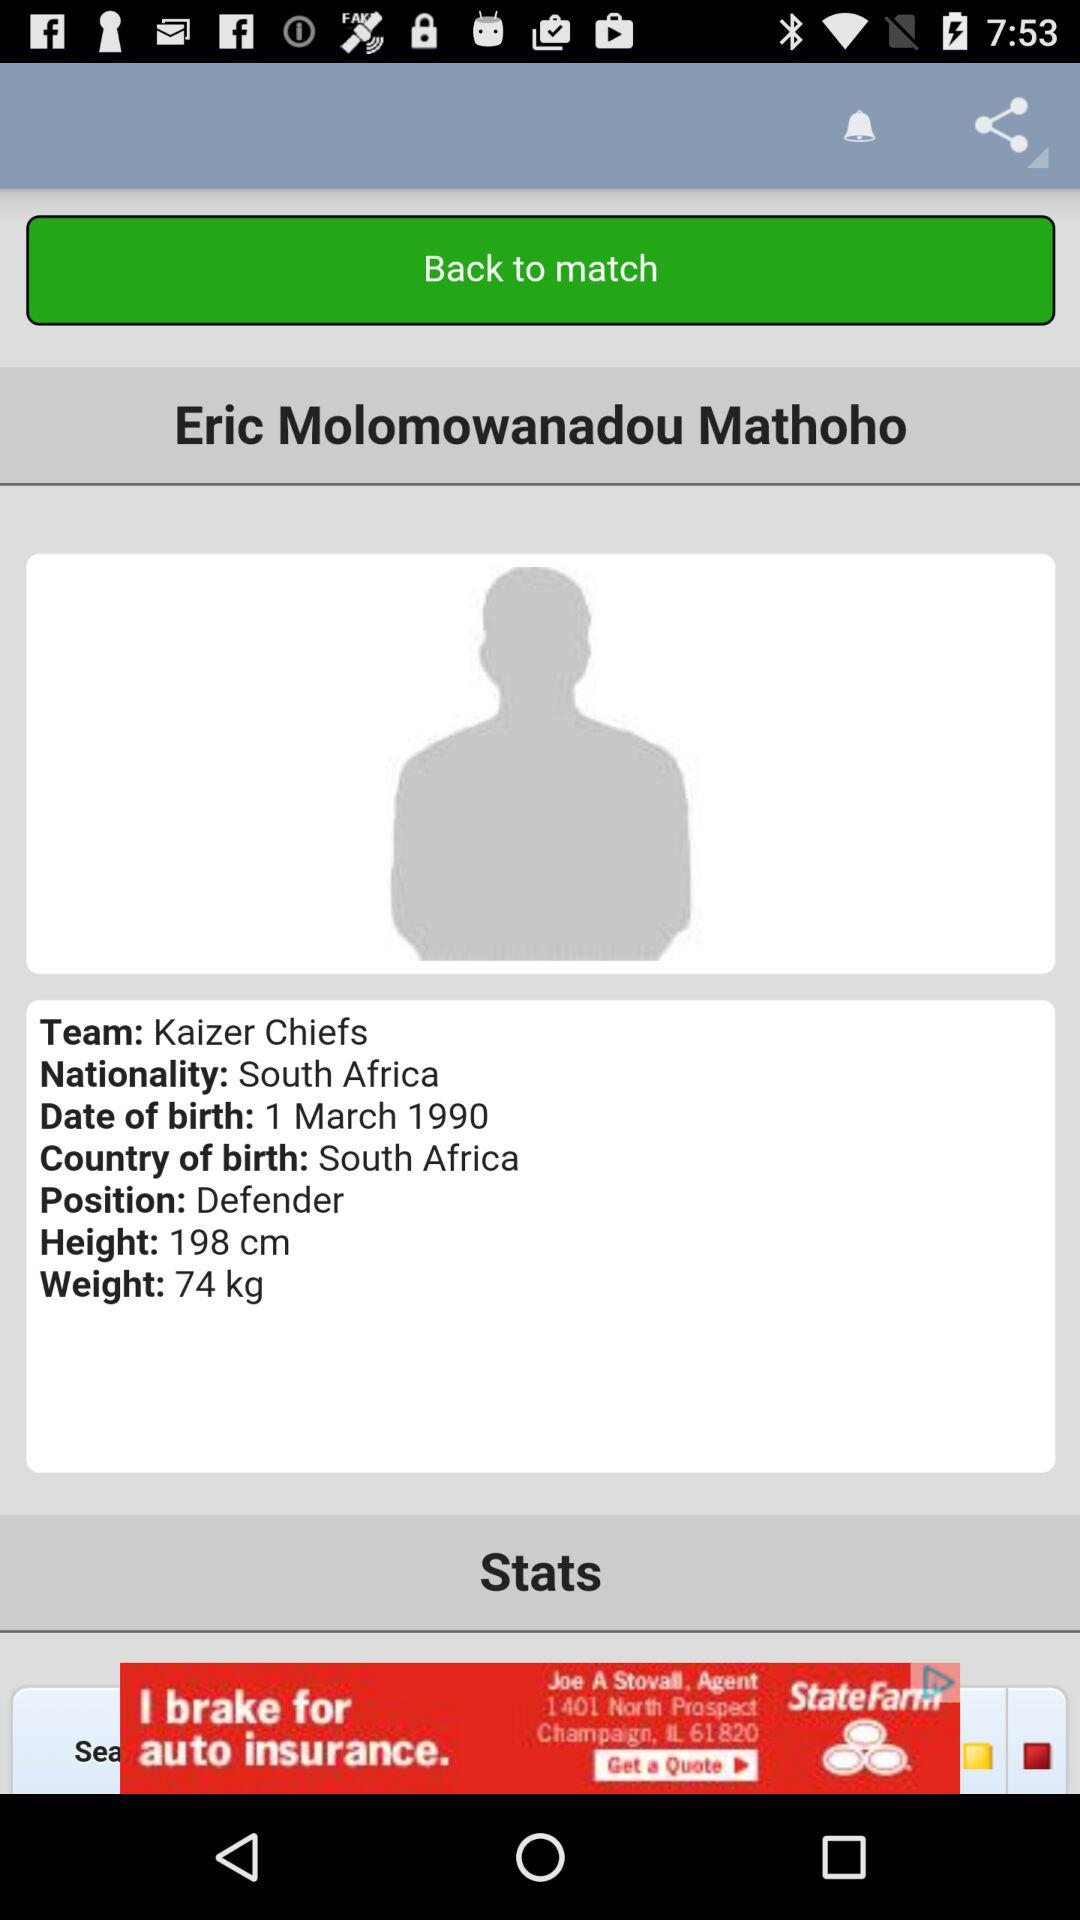At what position does the player play? The player play at defender position. 